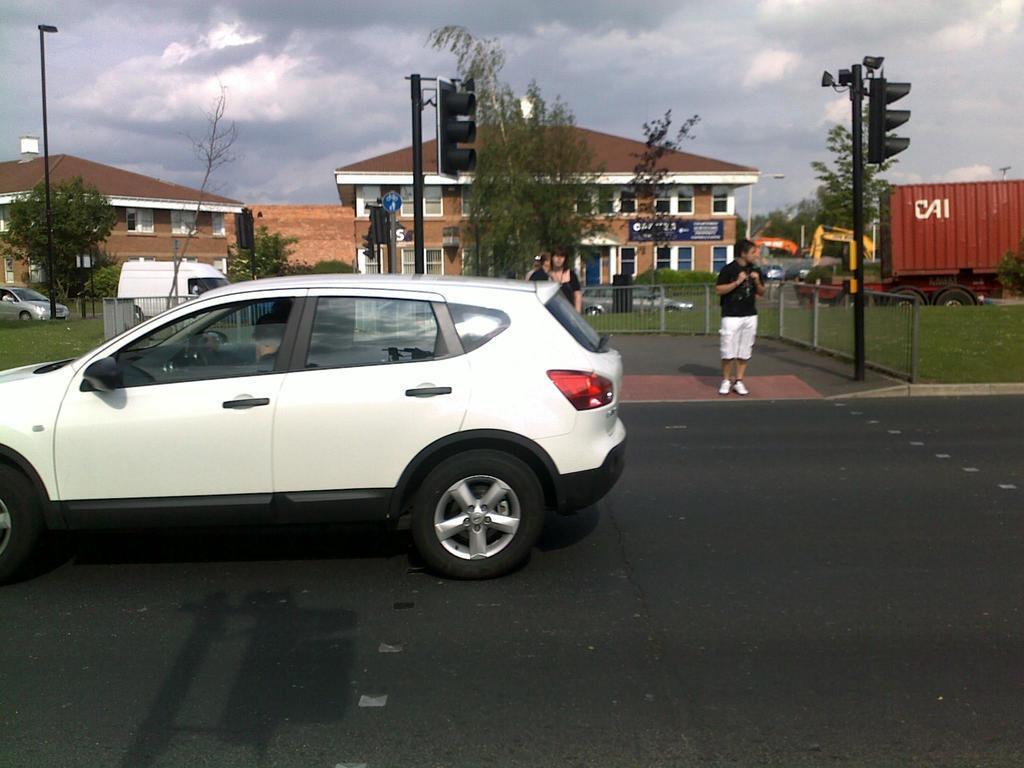In one or two sentences, can you explain what this image depicts? This image is taken outdoors. At the bottom of the image there is a road. At the top of the image there is a sky with clouds. On the right side of the image a car is parked on the road. In the middle of the image there are two houses with walls, windows, doors and roofs. There are a few poles with street lights and signal lights. A few vehicles are parked on the ground and there is a railing. On the right side of the image there are a few trees and there are a few vehicles on the ground. 